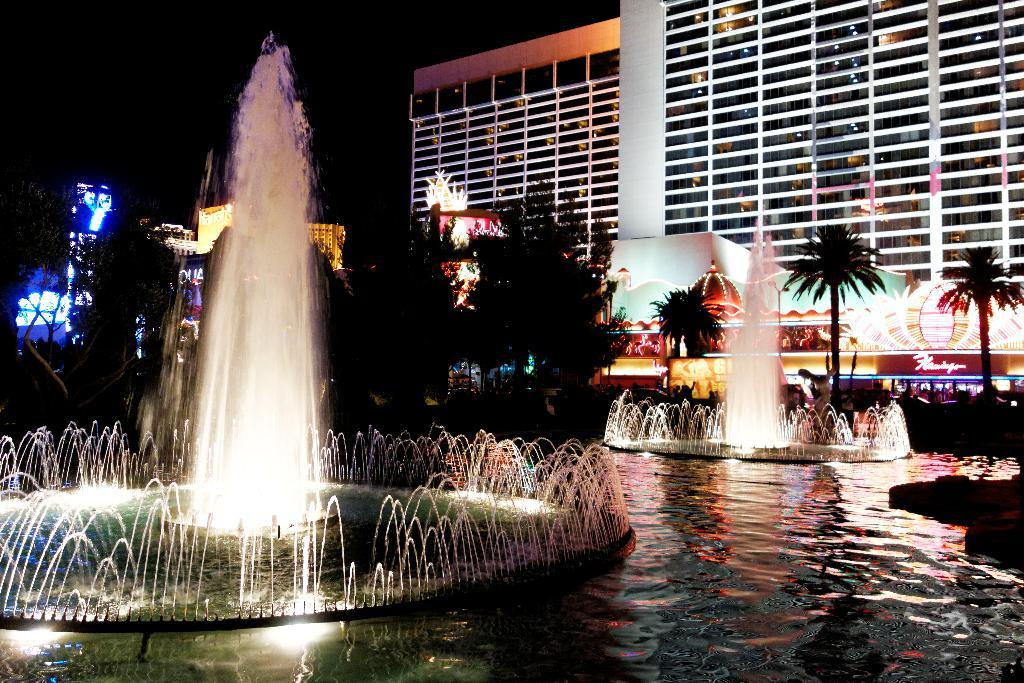What type of structures can be seen in the image? There are buildings in the image. What type of illumination is present in the image? Electric lights are present in the image. What can be seen in the sky in the image? The sky is visible in the image. What type of vegetation is present in the image? There are trees in the image. What type of water feature is present in the image? Fountains are present in the image. What type of liquid is visible in the image? Water is visible in the image. What type of temporary sales locations are present in the image? Stalls are present in the image. What type of bell can be heard ringing in the image? There is no bell present in the image, and therefore no sound can be heard. How many sons are visible in the image? There is no mention of a son or any people in the image, so it cannot be determined. 